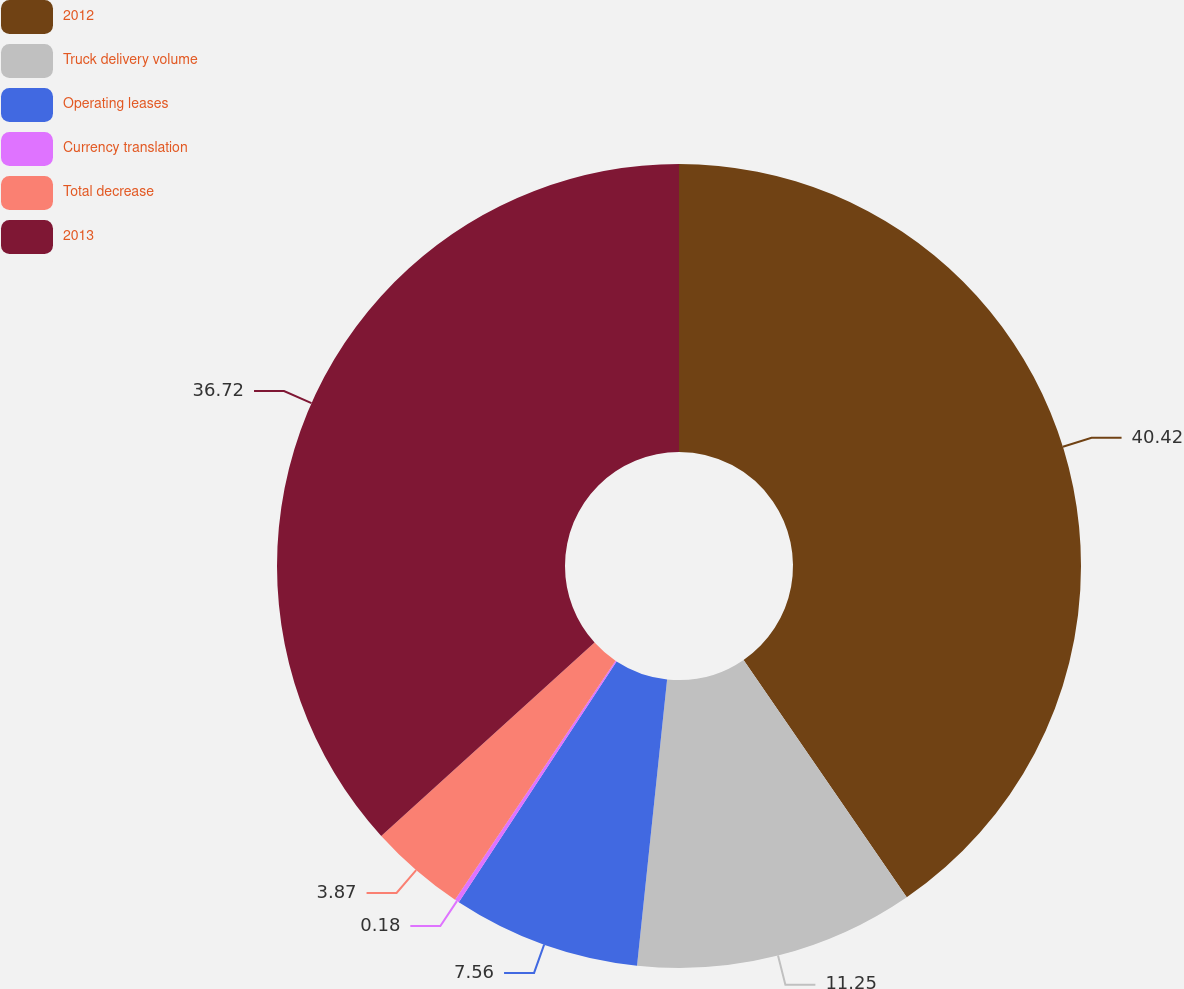<chart> <loc_0><loc_0><loc_500><loc_500><pie_chart><fcel>2012<fcel>Truck delivery volume<fcel>Operating leases<fcel>Currency translation<fcel>Total decrease<fcel>2013<nl><fcel>40.41%<fcel>11.25%<fcel>7.56%<fcel>0.18%<fcel>3.87%<fcel>36.72%<nl></chart> 